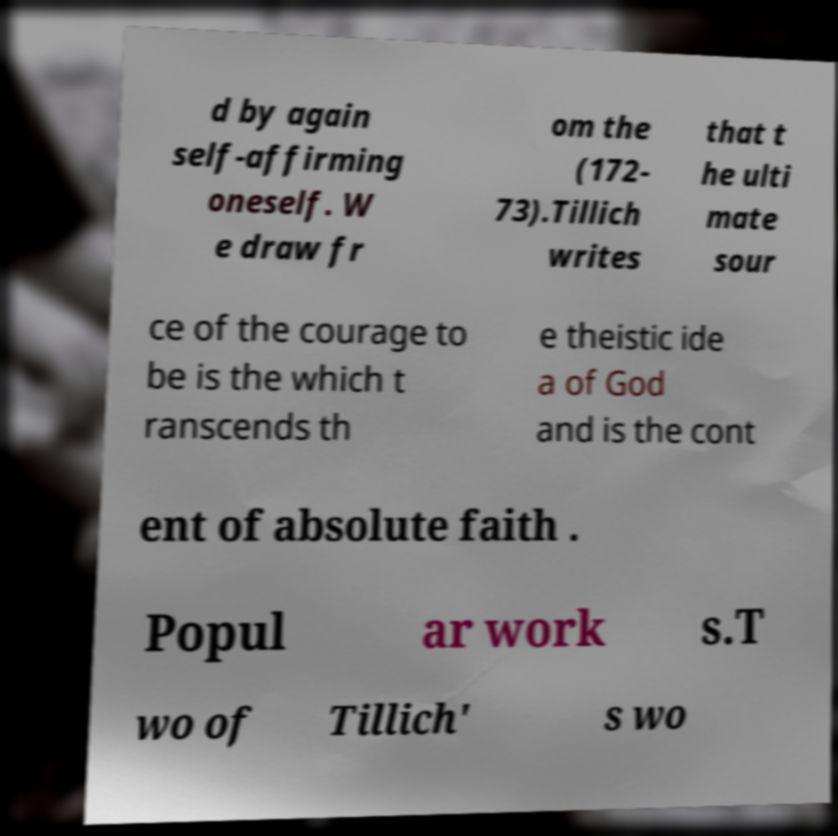There's text embedded in this image that I need extracted. Can you transcribe it verbatim? d by again self-affirming oneself. W e draw fr om the (172- 73).Tillich writes that t he ulti mate sour ce of the courage to be is the which t ranscends th e theistic ide a of God and is the cont ent of absolute faith . Popul ar work s.T wo of Tillich' s wo 